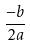Convert formula to latex. <formula><loc_0><loc_0><loc_500><loc_500>\frac { - b } { 2 a }</formula> 